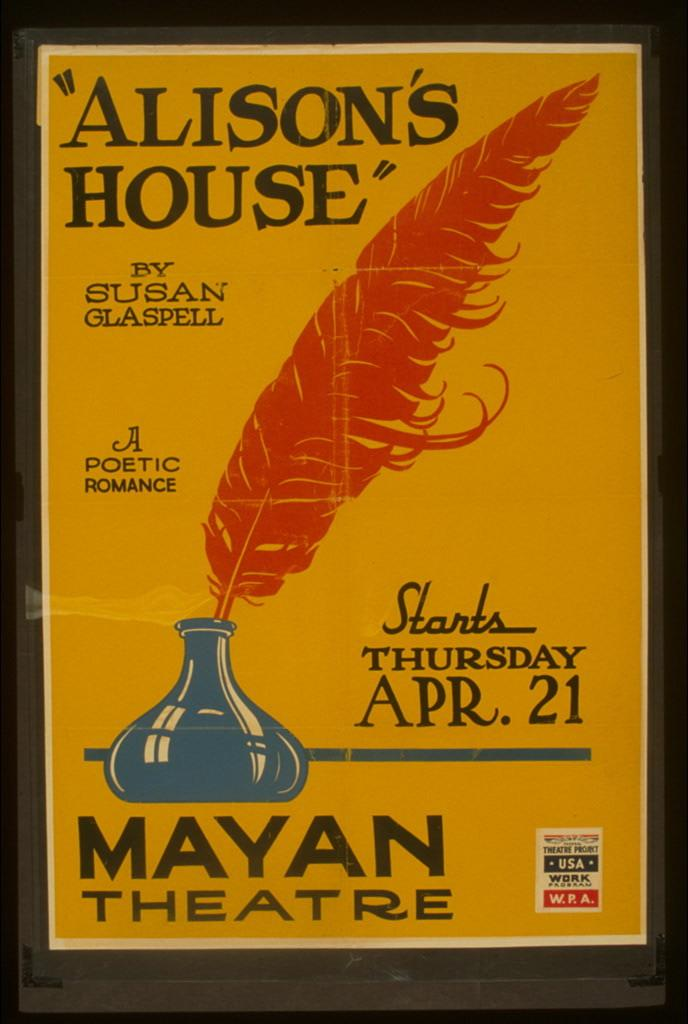<image>
Render a clear and concise summary of the photo. A yellow and orange poster advertising the play Alisons House at the Mayan Theatre in April. 